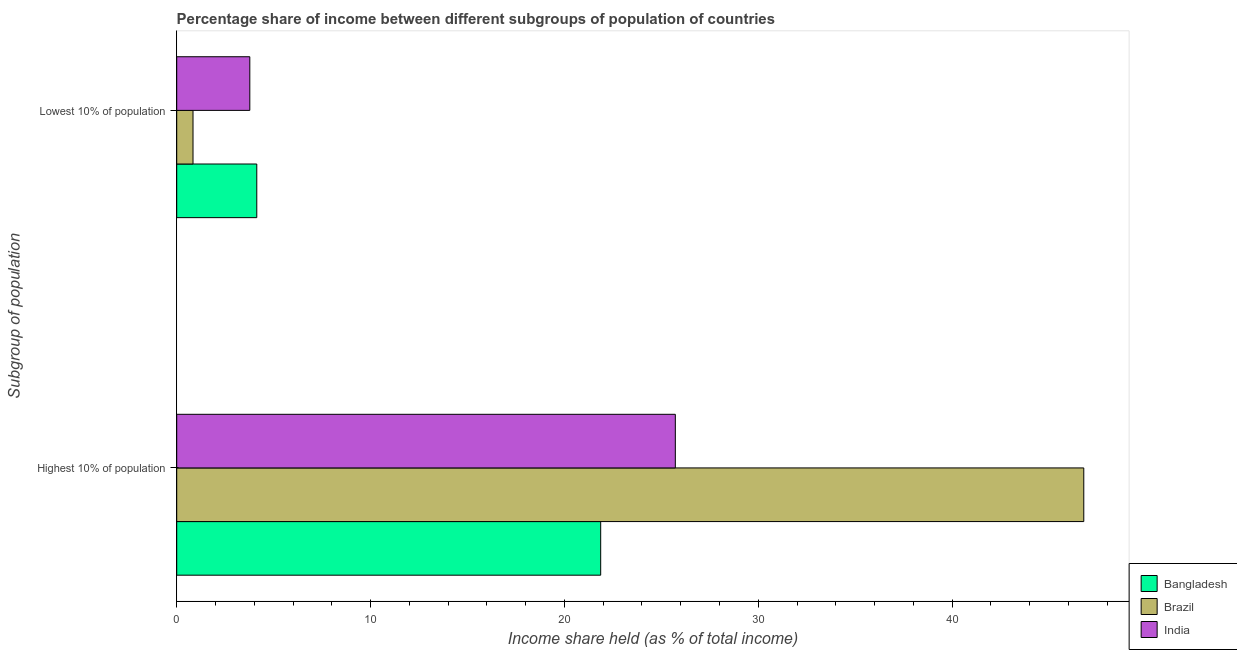How many groups of bars are there?
Offer a terse response. 2. Are the number of bars on each tick of the Y-axis equal?
Make the answer very short. Yes. How many bars are there on the 1st tick from the top?
Keep it short and to the point. 3. How many bars are there on the 1st tick from the bottom?
Provide a short and direct response. 3. What is the label of the 2nd group of bars from the top?
Make the answer very short. Highest 10% of population. What is the income share held by highest 10% of the population in Bangladesh?
Give a very brief answer. 21.87. Across all countries, what is the maximum income share held by lowest 10% of the population?
Your response must be concise. 4.13. Across all countries, what is the minimum income share held by lowest 10% of the population?
Offer a very short reply. 0.84. In which country was the income share held by highest 10% of the population minimum?
Offer a very short reply. Bangladesh. What is the total income share held by highest 10% of the population in the graph?
Provide a succinct answer. 94.38. What is the difference between the income share held by highest 10% of the population in India and that in Brazil?
Your response must be concise. -21.07. What is the average income share held by highest 10% of the population per country?
Give a very brief answer. 31.46. What is the difference between the income share held by lowest 10% of the population and income share held by highest 10% of the population in India?
Offer a terse response. -21.95. In how many countries, is the income share held by lowest 10% of the population greater than 38 %?
Your answer should be very brief. 0. What is the ratio of the income share held by highest 10% of the population in India to that in Brazil?
Make the answer very short. 0.55. In how many countries, is the income share held by lowest 10% of the population greater than the average income share held by lowest 10% of the population taken over all countries?
Make the answer very short. 2. What does the 2nd bar from the top in Lowest 10% of population represents?
Give a very brief answer. Brazil. How many bars are there?
Your answer should be compact. 6. Are all the bars in the graph horizontal?
Give a very brief answer. Yes. What is the difference between two consecutive major ticks on the X-axis?
Your answer should be compact. 10. Are the values on the major ticks of X-axis written in scientific E-notation?
Make the answer very short. No. Does the graph contain grids?
Your answer should be compact. No. How many legend labels are there?
Your response must be concise. 3. How are the legend labels stacked?
Offer a very short reply. Vertical. What is the title of the graph?
Your answer should be very brief. Percentage share of income between different subgroups of population of countries. Does "West Bank and Gaza" appear as one of the legend labels in the graph?
Give a very brief answer. No. What is the label or title of the X-axis?
Provide a succinct answer. Income share held (as % of total income). What is the label or title of the Y-axis?
Offer a very short reply. Subgroup of population. What is the Income share held (as % of total income) of Bangladesh in Highest 10% of population?
Offer a very short reply. 21.87. What is the Income share held (as % of total income) of Brazil in Highest 10% of population?
Make the answer very short. 46.79. What is the Income share held (as % of total income) of India in Highest 10% of population?
Offer a terse response. 25.72. What is the Income share held (as % of total income) in Bangladesh in Lowest 10% of population?
Offer a very short reply. 4.13. What is the Income share held (as % of total income) of Brazil in Lowest 10% of population?
Your answer should be very brief. 0.84. What is the Income share held (as % of total income) of India in Lowest 10% of population?
Provide a short and direct response. 3.77. Across all Subgroup of population, what is the maximum Income share held (as % of total income) in Bangladesh?
Your response must be concise. 21.87. Across all Subgroup of population, what is the maximum Income share held (as % of total income) in Brazil?
Provide a succinct answer. 46.79. Across all Subgroup of population, what is the maximum Income share held (as % of total income) of India?
Offer a terse response. 25.72. Across all Subgroup of population, what is the minimum Income share held (as % of total income) in Bangladesh?
Keep it short and to the point. 4.13. Across all Subgroup of population, what is the minimum Income share held (as % of total income) in Brazil?
Ensure brevity in your answer.  0.84. Across all Subgroup of population, what is the minimum Income share held (as % of total income) of India?
Offer a very short reply. 3.77. What is the total Income share held (as % of total income) of Bangladesh in the graph?
Provide a succinct answer. 26. What is the total Income share held (as % of total income) in Brazil in the graph?
Make the answer very short. 47.63. What is the total Income share held (as % of total income) in India in the graph?
Your answer should be very brief. 29.49. What is the difference between the Income share held (as % of total income) of Bangladesh in Highest 10% of population and that in Lowest 10% of population?
Offer a very short reply. 17.74. What is the difference between the Income share held (as % of total income) of Brazil in Highest 10% of population and that in Lowest 10% of population?
Ensure brevity in your answer.  45.95. What is the difference between the Income share held (as % of total income) of India in Highest 10% of population and that in Lowest 10% of population?
Make the answer very short. 21.95. What is the difference between the Income share held (as % of total income) of Bangladesh in Highest 10% of population and the Income share held (as % of total income) of Brazil in Lowest 10% of population?
Ensure brevity in your answer.  21.03. What is the difference between the Income share held (as % of total income) of Bangladesh in Highest 10% of population and the Income share held (as % of total income) of India in Lowest 10% of population?
Your answer should be compact. 18.1. What is the difference between the Income share held (as % of total income) of Brazil in Highest 10% of population and the Income share held (as % of total income) of India in Lowest 10% of population?
Give a very brief answer. 43.02. What is the average Income share held (as % of total income) of Bangladesh per Subgroup of population?
Provide a short and direct response. 13. What is the average Income share held (as % of total income) of Brazil per Subgroup of population?
Your answer should be very brief. 23.82. What is the average Income share held (as % of total income) in India per Subgroup of population?
Ensure brevity in your answer.  14.74. What is the difference between the Income share held (as % of total income) of Bangladesh and Income share held (as % of total income) of Brazil in Highest 10% of population?
Provide a short and direct response. -24.92. What is the difference between the Income share held (as % of total income) in Bangladesh and Income share held (as % of total income) in India in Highest 10% of population?
Provide a short and direct response. -3.85. What is the difference between the Income share held (as % of total income) in Brazil and Income share held (as % of total income) in India in Highest 10% of population?
Offer a terse response. 21.07. What is the difference between the Income share held (as % of total income) of Bangladesh and Income share held (as % of total income) of Brazil in Lowest 10% of population?
Your answer should be compact. 3.29. What is the difference between the Income share held (as % of total income) of Bangladesh and Income share held (as % of total income) of India in Lowest 10% of population?
Your response must be concise. 0.36. What is the difference between the Income share held (as % of total income) in Brazil and Income share held (as % of total income) in India in Lowest 10% of population?
Your answer should be very brief. -2.93. What is the ratio of the Income share held (as % of total income) of Bangladesh in Highest 10% of population to that in Lowest 10% of population?
Provide a short and direct response. 5.3. What is the ratio of the Income share held (as % of total income) of Brazil in Highest 10% of population to that in Lowest 10% of population?
Your answer should be very brief. 55.7. What is the ratio of the Income share held (as % of total income) of India in Highest 10% of population to that in Lowest 10% of population?
Provide a short and direct response. 6.82. What is the difference between the highest and the second highest Income share held (as % of total income) in Bangladesh?
Provide a succinct answer. 17.74. What is the difference between the highest and the second highest Income share held (as % of total income) of Brazil?
Your answer should be compact. 45.95. What is the difference between the highest and the second highest Income share held (as % of total income) in India?
Provide a short and direct response. 21.95. What is the difference between the highest and the lowest Income share held (as % of total income) of Bangladesh?
Your answer should be very brief. 17.74. What is the difference between the highest and the lowest Income share held (as % of total income) in Brazil?
Give a very brief answer. 45.95. What is the difference between the highest and the lowest Income share held (as % of total income) in India?
Provide a succinct answer. 21.95. 